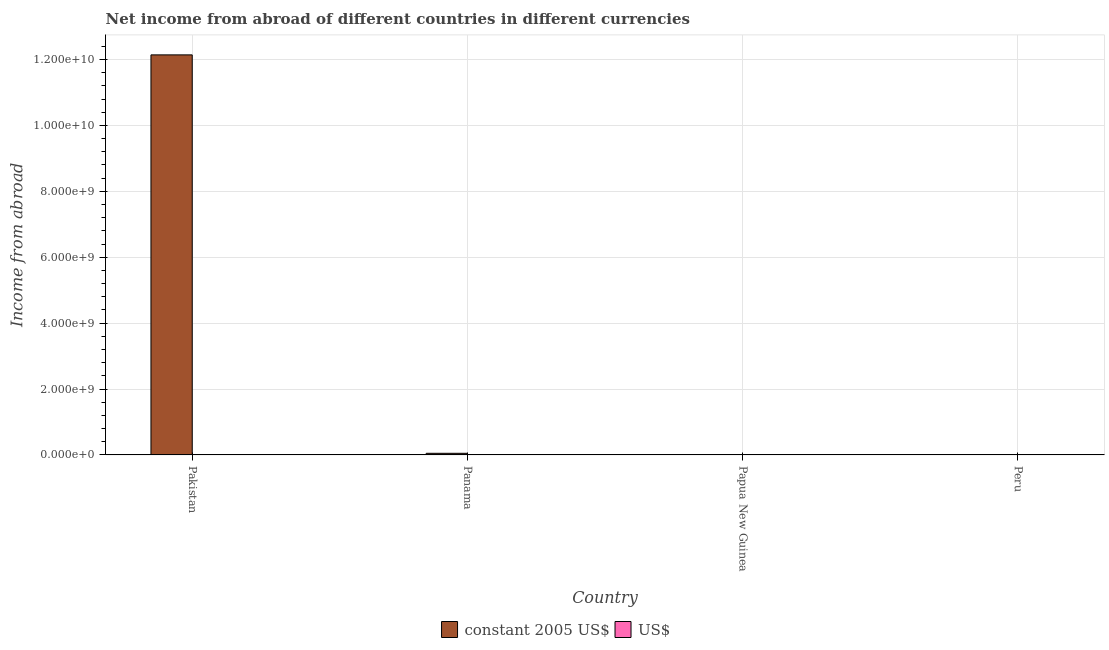How many different coloured bars are there?
Give a very brief answer. 1. Are the number of bars per tick equal to the number of legend labels?
Provide a succinct answer. No. How many bars are there on the 1st tick from the right?
Offer a very short reply. 0. What is the label of the 4th group of bars from the left?
Provide a succinct answer. Peru. Across all countries, what is the maximum income from abroad in constant 2005 us$?
Offer a terse response. 1.21e+1. Across all countries, what is the minimum income from abroad in constant 2005 us$?
Give a very brief answer. 0. In which country was the income from abroad in constant 2005 us$ maximum?
Your answer should be very brief. Pakistan. What is the total income from abroad in us$ in the graph?
Ensure brevity in your answer.  0. What is the difference between the income from abroad in us$ in Papua New Guinea and the income from abroad in constant 2005 us$ in Pakistan?
Ensure brevity in your answer.  -1.21e+1. What is the average income from abroad in constant 2005 us$ per country?
Offer a terse response. 3.05e+09. In how many countries, is the income from abroad in us$ greater than 4400000000 units?
Ensure brevity in your answer.  0. What is the ratio of the income from abroad in constant 2005 us$ in Pakistan to that in Panama?
Your answer should be compact. 246.23. What is the difference between the highest and the lowest income from abroad in constant 2005 us$?
Provide a succinct answer. 1.21e+1. In how many countries, is the income from abroad in us$ greater than the average income from abroad in us$ taken over all countries?
Offer a terse response. 0. Is the sum of the income from abroad in constant 2005 us$ in Pakistan and Panama greater than the maximum income from abroad in us$ across all countries?
Your answer should be very brief. Yes. How many bars are there?
Your response must be concise. 2. How many countries are there in the graph?
Give a very brief answer. 4. Are the values on the major ticks of Y-axis written in scientific E-notation?
Your answer should be compact. Yes. Does the graph contain grids?
Offer a terse response. Yes. Where does the legend appear in the graph?
Provide a succinct answer. Bottom center. How are the legend labels stacked?
Offer a very short reply. Horizontal. What is the title of the graph?
Make the answer very short. Net income from abroad of different countries in different currencies. What is the label or title of the X-axis?
Make the answer very short. Country. What is the label or title of the Y-axis?
Your response must be concise. Income from abroad. What is the Income from abroad in constant 2005 US$ in Pakistan?
Ensure brevity in your answer.  1.21e+1. What is the Income from abroad in US$ in Pakistan?
Offer a very short reply. 0. What is the Income from abroad in constant 2005 US$ in Panama?
Provide a short and direct response. 4.93e+07. What is the Income from abroad in US$ in Peru?
Provide a succinct answer. 0. Across all countries, what is the maximum Income from abroad of constant 2005 US$?
Your answer should be compact. 1.21e+1. Across all countries, what is the minimum Income from abroad in constant 2005 US$?
Offer a terse response. 0. What is the total Income from abroad of constant 2005 US$ in the graph?
Keep it short and to the point. 1.22e+1. What is the total Income from abroad in US$ in the graph?
Your answer should be compact. 0. What is the difference between the Income from abroad in constant 2005 US$ in Pakistan and that in Panama?
Your answer should be very brief. 1.21e+1. What is the average Income from abroad in constant 2005 US$ per country?
Your answer should be compact. 3.05e+09. What is the ratio of the Income from abroad in constant 2005 US$ in Pakistan to that in Panama?
Ensure brevity in your answer.  246.23. What is the difference between the highest and the lowest Income from abroad in constant 2005 US$?
Your answer should be very brief. 1.21e+1. 